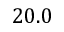Convert formula to latex. <formula><loc_0><loc_0><loc_500><loc_500>2 0 . 0</formula> 